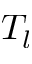<formula> <loc_0><loc_0><loc_500><loc_500>T _ { l }</formula> 